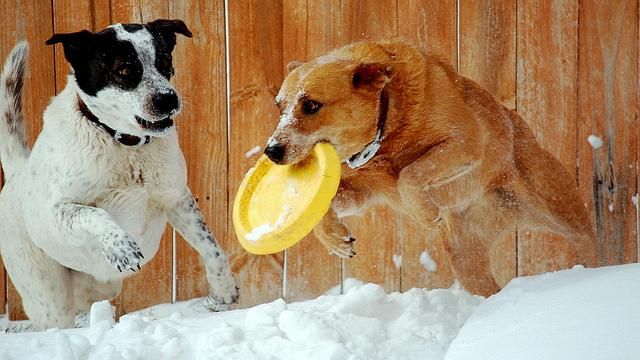What game are they playing?

Choices:
A) running
B) fetch
C) stretching
D) tag fetch 